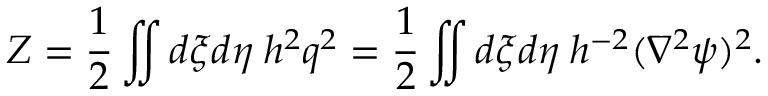<formula> <loc_0><loc_0><loc_500><loc_500>Z = \frac { 1 } { 2 } \iint d \xi d \eta \, h ^ { 2 } q ^ { 2 } = \frac { 1 } { 2 } \iint d \xi d \eta \, h ^ { - 2 } ( \nabla ^ { 2 } \psi ) ^ { 2 } .</formula> 